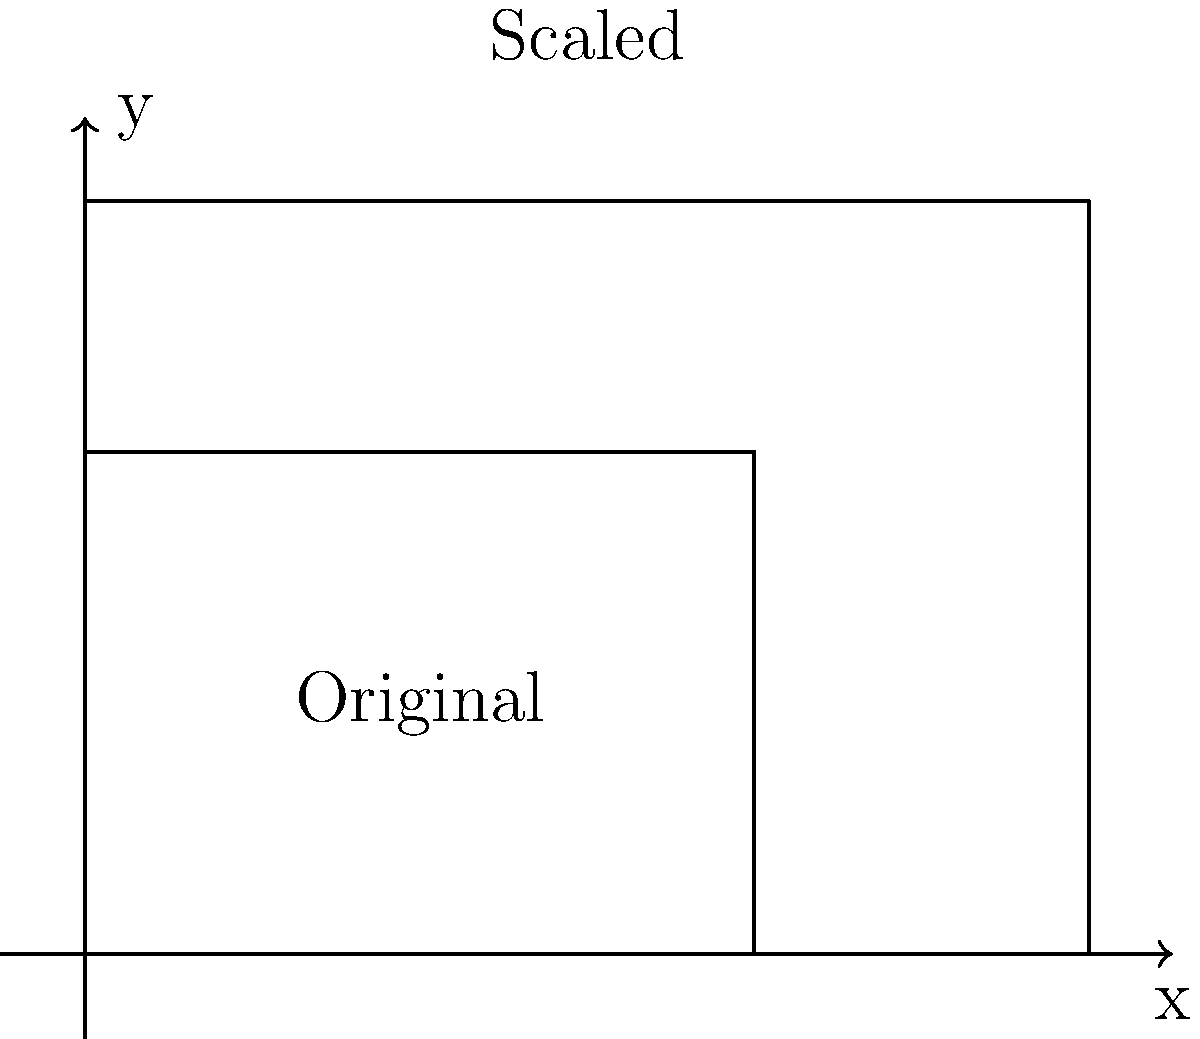As a tech entrepreneur, you're designing a new smartphone. The original blueprint measures 4 cm by 3 cm. You decide to scale it up for a larger model, resulting in a new blueprint measuring 6 cm by 4.5 cm. What is the scale factor used for this transformation? To find the scale factor, we need to compare the corresponding dimensions of the original and scaled blueprints:

1. Compare the widths:
   Original width = 4 cm
   Scaled width = 6 cm
   Ratio = $\frac{6}{4} = 1.5$

2. Compare the heights:
   Original height = 3 cm
   Scaled height = 4.5 cm
   Ratio = $\frac{4.5}{3} = 1.5$

3. Verify that both ratios are the same:
   Width ratio = Height ratio = 1.5

4. Therefore, the scale factor is 1.5, which means the original blueprint was enlarged by a factor of 1.5 in both dimensions.

We can express this mathematically as:

$$(x', y') = (1.5x, 1.5y)$$

where $(x, y)$ are the coordinates of any point on the original blueprint, and $(x', y')$ are the corresponding coordinates on the scaled blueprint.
Answer: 1.5 